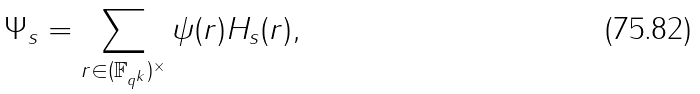Convert formula to latex. <formula><loc_0><loc_0><loc_500><loc_500>\Psi _ { s } = \sum _ { r \in ( \mathbb { F } _ { q ^ { k } } ) ^ { \times } } \psi ( r ) H _ { s } ( r ) ,</formula> 